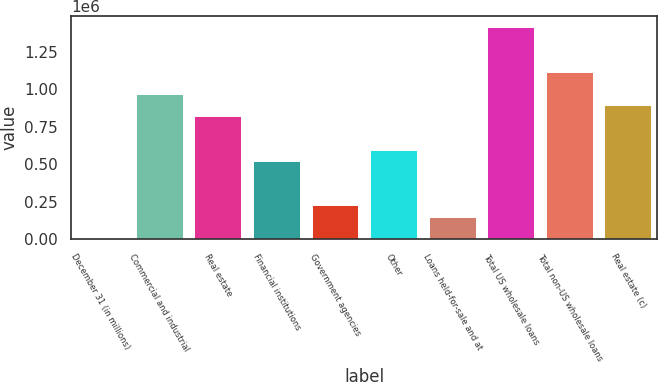Convert chart. <chart><loc_0><loc_0><loc_500><loc_500><bar_chart><fcel>December 31 (in millions)<fcel>Commercial and industrial<fcel>Real estate<fcel>Financial institutions<fcel>Government agencies<fcel>Other<fcel>Loans held-for-sale and at<fcel>Total US wholesale loans<fcel>Total non-US wholesale loans<fcel>Real estate (c)<nl><fcel>2008<fcel>967765<fcel>819187<fcel>522031<fcel>224875<fcel>596320<fcel>150586<fcel>1.4135e+06<fcel>1.11634e+06<fcel>893476<nl></chart> 